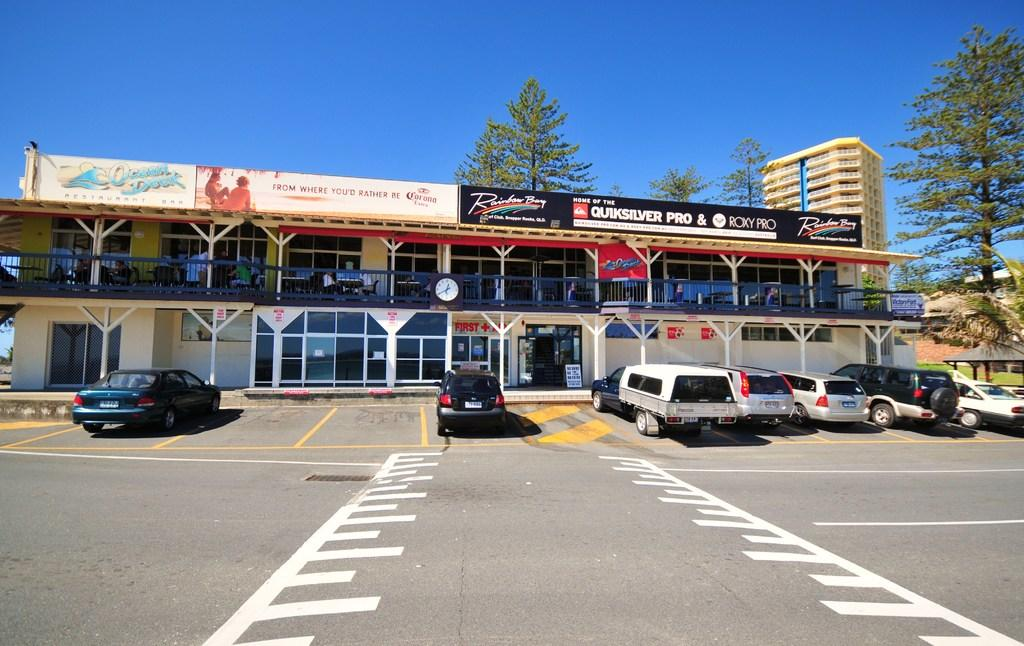What type of structures are present in the image? There are buildings in the image. What can be seen on the road in front of the buildings? Cars are parked on the road in front of the buildings. What type of vegetation is visible in the background of the image? There are trees visible in the background of the image. What else can be seen in the background of the image? The sky is visible in the background of the image. What room does the writer use to achieve their goals in the image? There is no writer or room mentioned in the image, and no information about achieving goals is provided. 